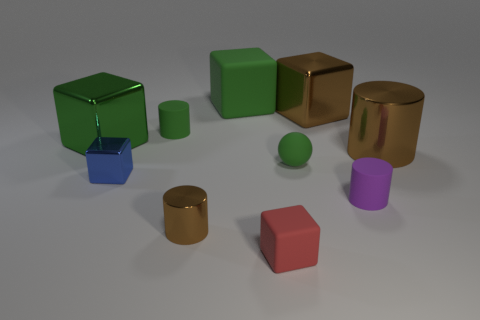Subtract 2 cubes. How many cubes are left? 3 Subtract all large brown cubes. How many cubes are left? 4 Subtract all brown cubes. How many cubes are left? 4 Subtract all gray cubes. Subtract all blue cylinders. How many cubes are left? 5 Subtract all balls. How many objects are left? 9 Subtract all red matte objects. Subtract all brown shiny objects. How many objects are left? 6 Add 4 tiny blue metallic things. How many tiny blue metallic things are left? 5 Add 4 green cubes. How many green cubes exist? 6 Subtract 0 yellow balls. How many objects are left? 10 